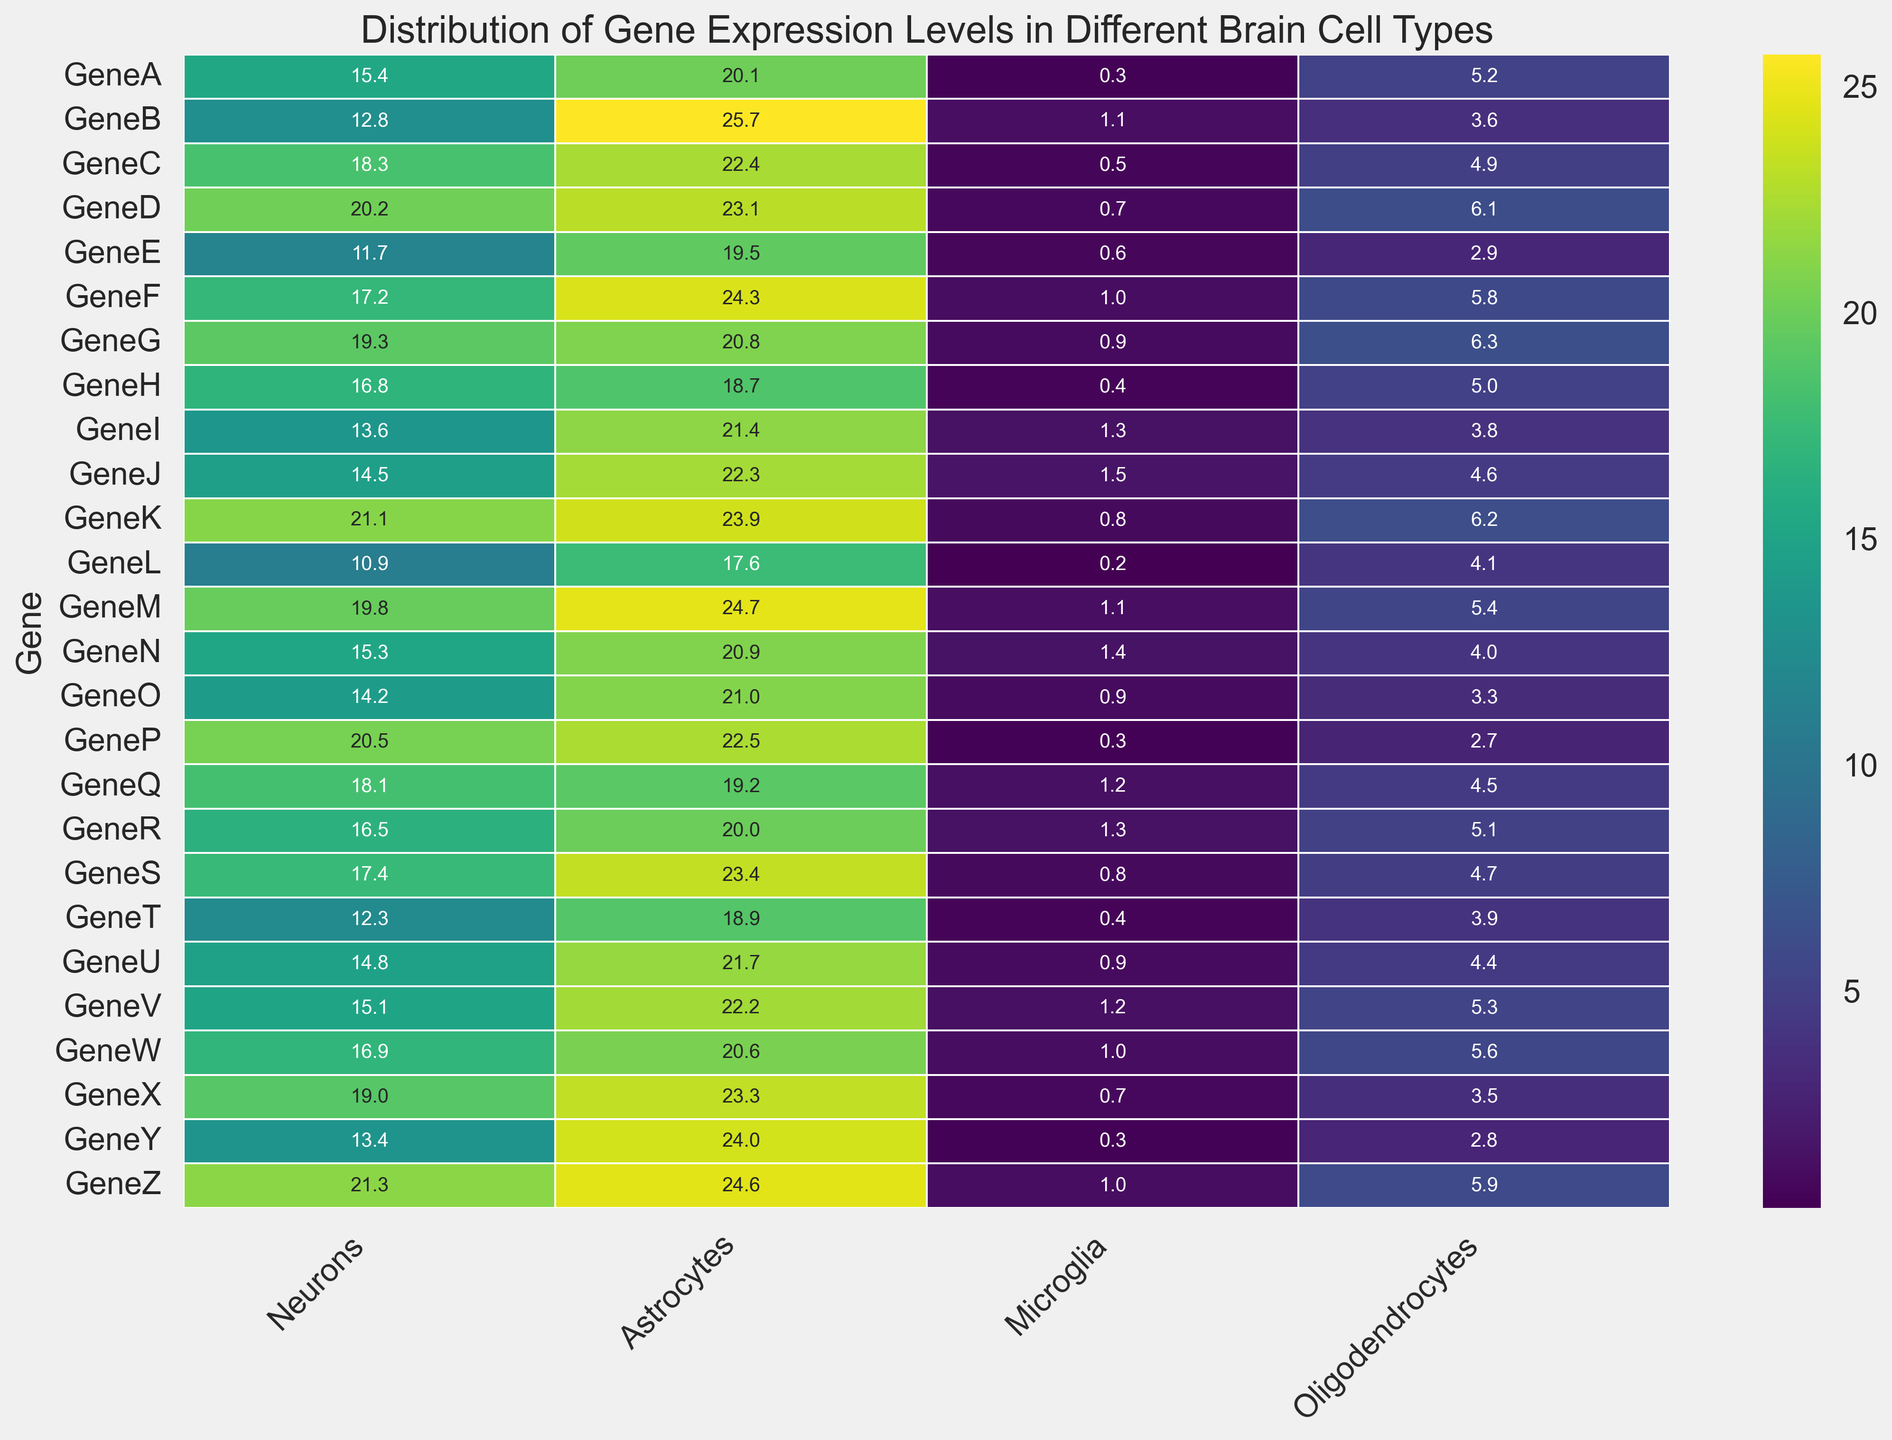Which cell type shows the highest gene expression level for GeneA? Look at the heatmap for the cell type with the highest value for GeneA.
Answer: Astrocytes Which gene is most highly expressed in Oligodendrocytes? Scan the Oligodendrocytes column for the highest value
Answer: GeneG Which cell type shows the lowest average gene expression across all genes? Calculate the average expression for each cell type and compare them.
Answer: Microglia What is the sum of gene expression levels for GeneD across all cell types? Add the expression levels of GeneD across Neurons, Astrocytes, Microglia, and Oligodendrocytes. Sum = 20.2 + 23.1 + 0.7 + 6.1
Answer: 50.1 Which cell type has more genes with expression levels greater than 20? Count the number of genes for each cell type with values greater than 20.
Answer: Astrocytes What is the difference in gene expression levels between GeneP and GeneT in Neurons? Subtract the value of GeneT from GeneP in Neurons. Difference = 20.5 - 12.3
Answer: 8.2 For which genes do Neurons and Oligodendrocytes have exactly the same expression levels? Examine the Neurons and Oligodendrocytes columns for identical values.
Answer: None What is the average expression level for GeneZ across all cell types? Calculate the mean of GeneZ’s expression levels in Neurons, Astrocytes, Microglia, and Oligodendrocytes. Mean = (21.3 + 24.6 + 1.0 + 5.9)/4
Answer: 13.2 Which cell type shows the greatest variability in gene expression levels? Determine the cell type with the highest standard deviation or range in values.
Answer: Astrocytes 